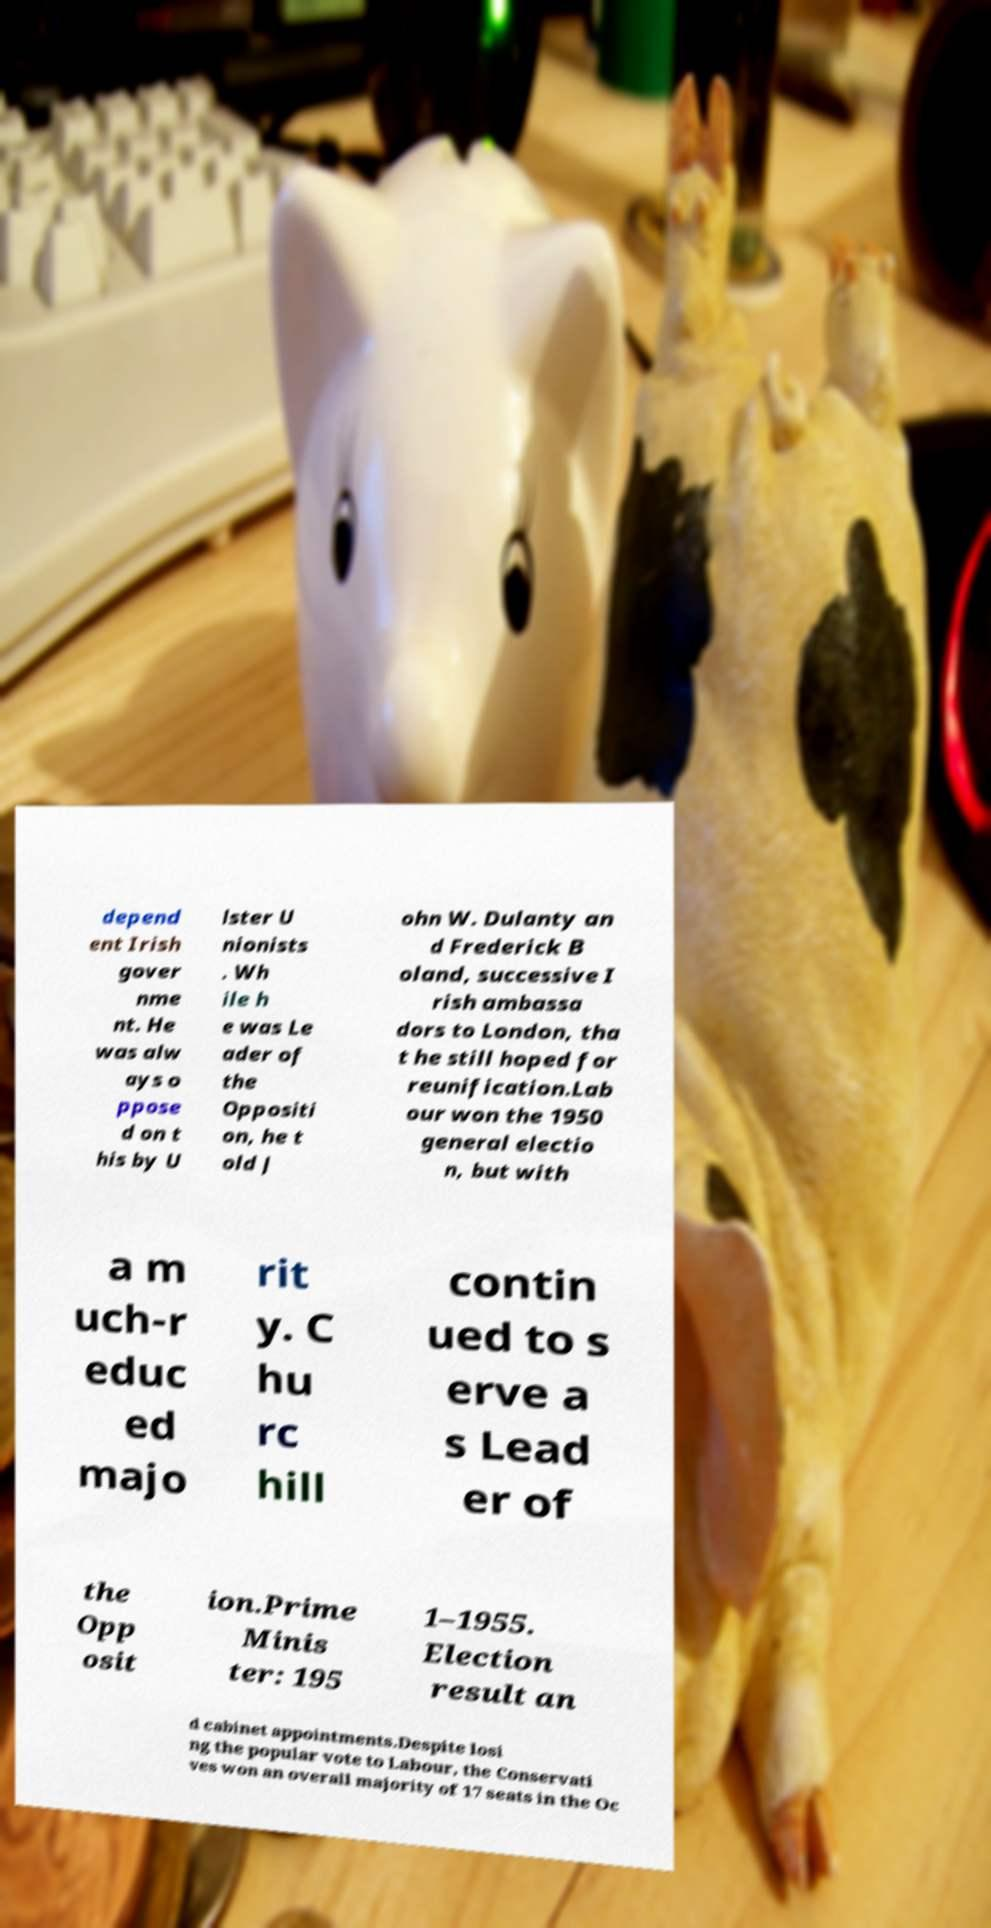What messages or text are displayed in this image? I need them in a readable, typed format. depend ent Irish gover nme nt. He was alw ays o ppose d on t his by U lster U nionists . Wh ile h e was Le ader of the Oppositi on, he t old J ohn W. Dulanty an d Frederick B oland, successive I rish ambassa dors to London, tha t he still hoped for reunification.Lab our won the 1950 general electio n, but with a m uch-r educ ed majo rit y. C hu rc hill contin ued to s erve a s Lead er of the Opp osit ion.Prime Minis ter: 195 1–1955. Election result an d cabinet appointments.Despite losi ng the popular vote to Labour, the Conservati ves won an overall majority of 17 seats in the Oc 